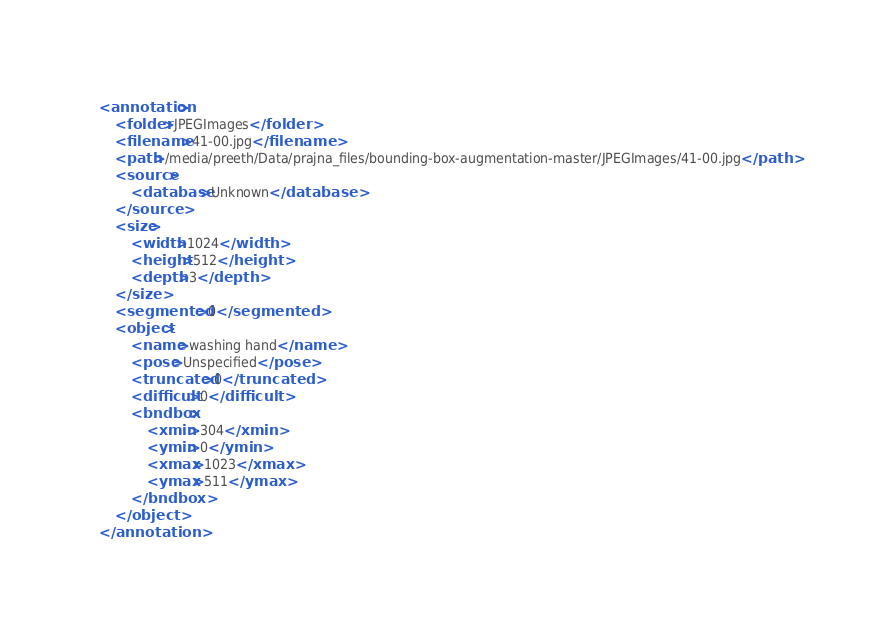Convert code to text. <code><loc_0><loc_0><loc_500><loc_500><_XML_><annotation>
    <folder>JPEGImages</folder>
    <filename>41-00.jpg</filename>
    <path>/media/preeth/Data/prajna_files/bounding-box-augmentation-master/JPEGImages/41-00.jpg</path>
    <source>
        <database>Unknown</database>
    </source>
    <size>
        <width>1024</width>
        <height>512</height>
        <depth>3</depth>
    </size>
    <segmented>0</segmented>
    <object>
        <name>washing hand</name>
        <pose>Unspecified</pose>
        <truncated>0</truncated>
        <difficult>0</difficult>
        <bndbox>
            <xmin>304</xmin>
            <ymin>0</ymin>
            <xmax>1023</xmax>
            <ymax>511</ymax>
        </bndbox>
    </object>
</annotation>
</code> 